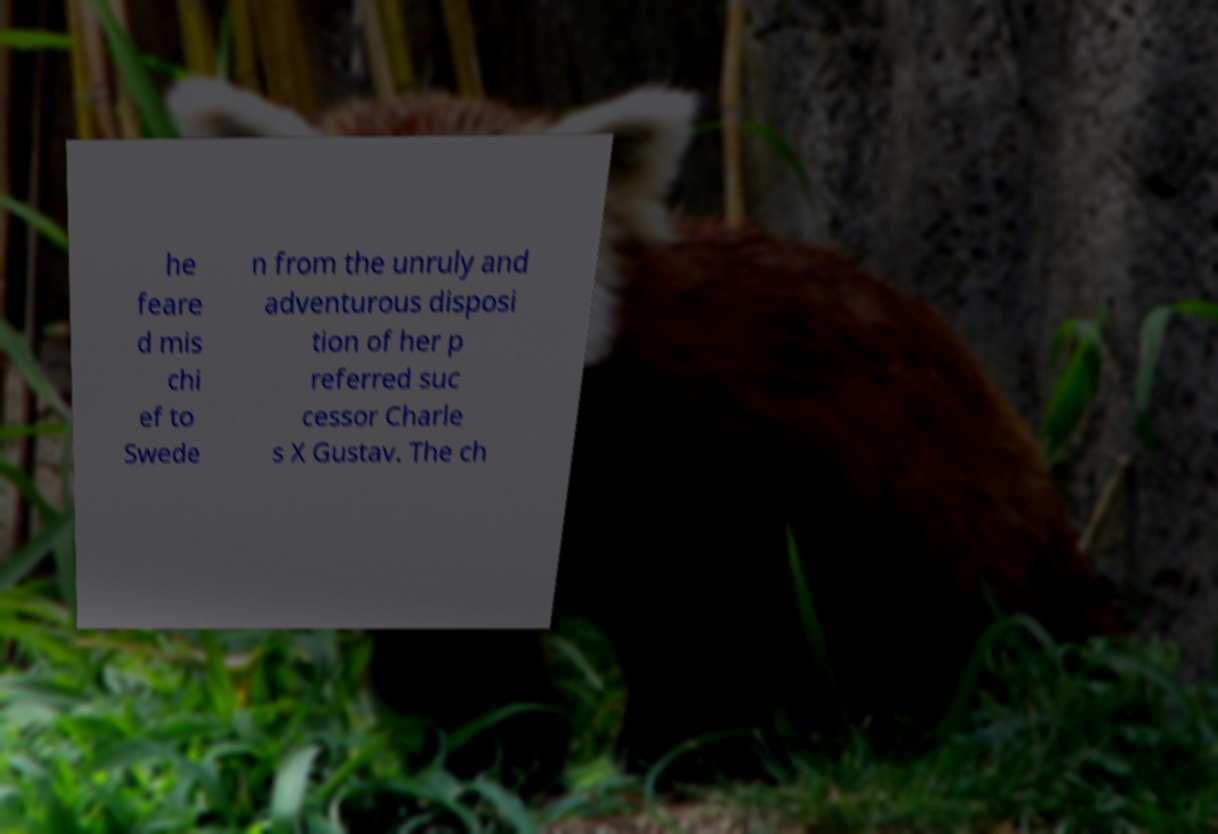Can you read and provide the text displayed in the image?This photo seems to have some interesting text. Can you extract and type it out for me? he feare d mis chi ef to Swede n from the unruly and adventurous disposi tion of her p referred suc cessor Charle s X Gustav. The ch 